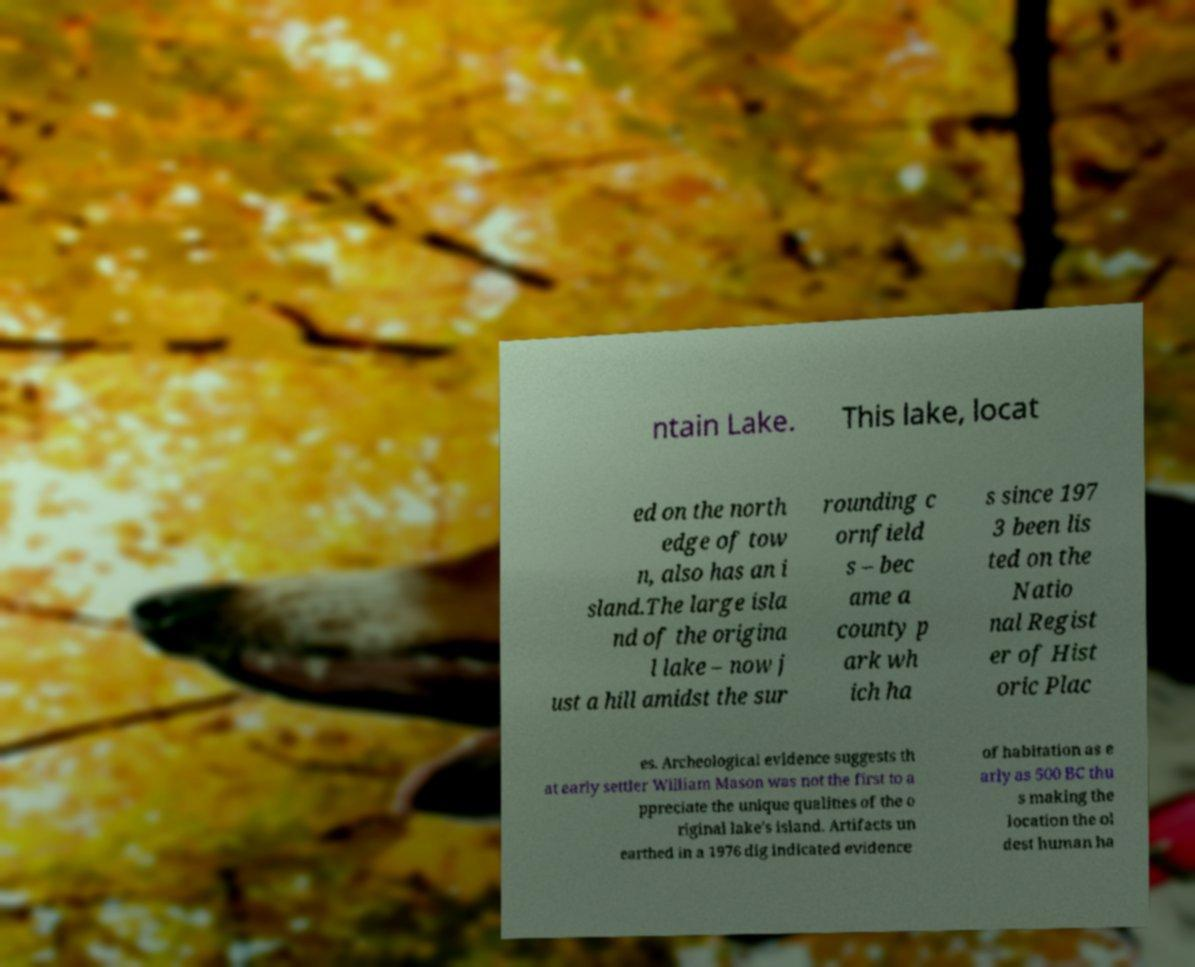For documentation purposes, I need the text within this image transcribed. Could you provide that? ntain Lake. This lake, locat ed on the north edge of tow n, also has an i sland.The large isla nd of the origina l lake – now j ust a hill amidst the sur rounding c ornfield s – bec ame a county p ark wh ich ha s since 197 3 been lis ted on the Natio nal Regist er of Hist oric Plac es. Archeological evidence suggests th at early settler William Mason was not the first to a ppreciate the unique qualities of the o riginal lake's island. Artifacts un earthed in a 1976 dig indicated evidence of habitation as e arly as 500 BC thu s making the location the ol dest human ha 